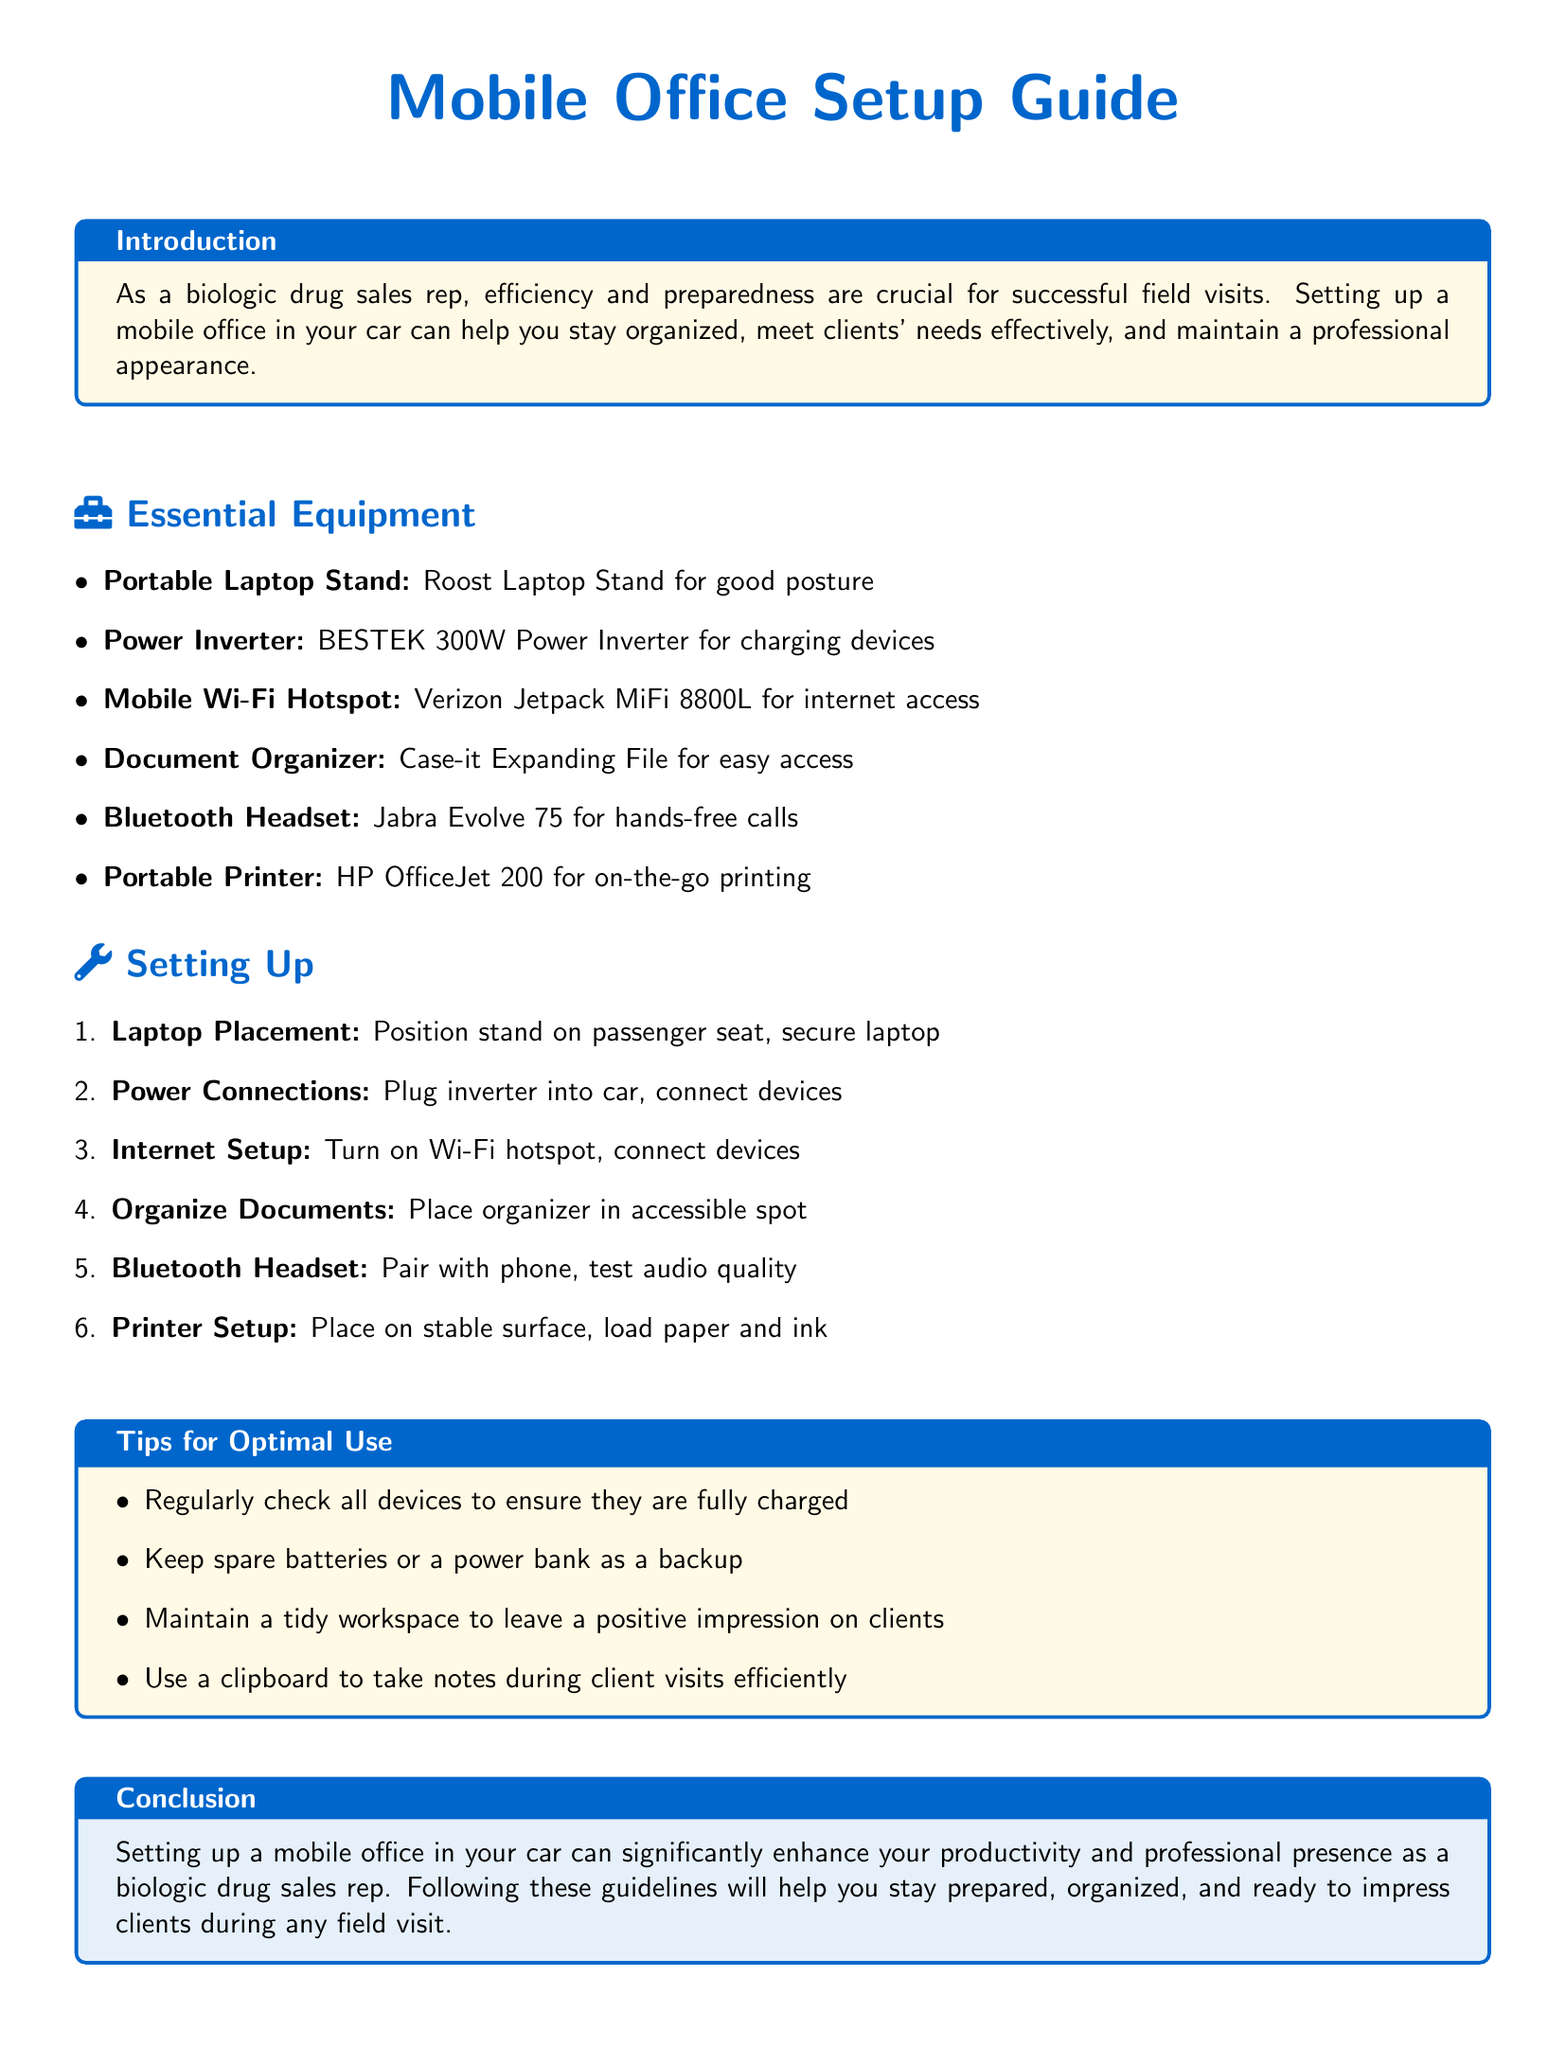What is the title of the document? The title of the document is prominently displayed at the top as "Mobile Office Setup Guide."
Answer: Mobile Office Setup Guide What is the first essential equipment listed? The first item in the list of essential equipment is a "Portable Laptop Stand."
Answer: Portable Laptop Stand How many steps are there in the setting up process? The document enumerates six steps required to set up the mobile office.
Answer: 6 What device is recommended for internet access? The document suggests using the "Verizon Jetpack MiFi 8800L" for internet access.
Answer: Verizon Jetpack MiFi 8800L What is one tip for optimal use mentioned? One of the tips listed advises to "Regularly check all devices to ensure they are fully charged."
Answer: Regularly check all devices to ensure they are fully charged Which section provides an introduction? The introduction is found in the "Introduction" section within a tcolorbox.
Answer: Introduction What type of document is this? The document is an assembly instruction guide for setting up a mobile office space in a car.
Answer: assembly instruction guide What item is suggested to keep for a backup? The tips suggest keeping "spare batteries or a power bank as a backup."
Answer: spare batteries or a power bank How should the laptop be positioned according to the setup instructions? The setup instructions state that the laptop should be "Position stand on passenger seat, secure laptop."
Answer: Position stand on passenger seat, secure laptop 